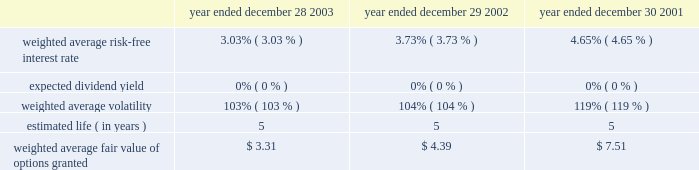Illumina , inc .
Notes to consolidated financial statements 2014 ( continued ) advertising costs the company expenses advertising costs as incurred .
Advertising costs were approximately $ 440000 for 2003 , $ 267000 for 2002 and $ 57000 for 2001 .
Income taxes a deferred income tax asset or liability is computed for the expected future impact of differences between the financial reporting and tax bases of assets and liabilities , as well as the expected future tax benefit to be derived from tax loss and credit carryforwards .
Deferred income tax expense is generally the net change during the year in the deferred income tax asset or liability .
Valuation allowances are established when realizability of deferred tax assets is uncertain .
The effect of tax rate changes is reflected in tax expense during the period in which such changes are enacted .
Foreign currency translation the functional currencies of the company 2019s wholly owned subsidiaries are their respective local currencies .
Accordingly , all balance sheet accounts of these operations are translated to u.s .
Dollars using the exchange rates in effect at the balance sheet date , and revenues and expenses are translated using the average exchange rates in effect during the period .
The gains and losses from foreign currency translation of these subsidiaries 2019 financial statements are recorded directly as a separate component of stockholders 2019 equity under the caption 2018 2018accumulated other comprehensive income . 2019 2019 stock-based compensation at december 28 , 2003 , the company has three stock-based employee and non-employee director compensation plans , which are described more fully in note 5 .
As permitted by sfas no .
123 , accounting for stock-based compensation , the company accounts for common stock options granted , and restricted stock sold , to employees , founders and directors using the intrinsic value method and , thus , recognizes no compensation expense for options granted , or restricted stock sold , with exercise prices equal to or greater than the fair value of the company 2019s common stock on the date of the grant .
The company has recorded deferred stock compensation related to certain stock options , and restricted stock , which were granted prior to the company 2019s initial public offering with exercise prices below estimated fair value ( see note 5 ) , which is being amortized on an accelerated amortiza- tion methodology in accordance with financial accounting standards board interpretation number ( 2018 2018fin 2019 2019 ) 28 .
Pro forma information regarding net loss is required by sfas no .
123 and has been determined as if the company had accounted for its employee stock options and employee stock purchases under the fair value method of that statement .
The fair value for these options was estimated at the dates of grant using the fair value option pricing model ( black scholes ) with the following weighted-average assumptions for 2003 , 2002 and 2001 : year ended year ended year ended december 28 , december 29 , december 30 , 2003 2002 2001 weighted average risk-free interest rate******* 3.03% ( 3.03 % ) 3.73% ( 3.73 % ) 4.65% ( 4.65 % ) expected dividend yield********************* 0% ( 0 % ) 0% ( 0 % ) 0% ( 0 % ) weighted average volatility ****************** 103% ( 103 % ) 104% ( 104 % ) 119% ( 119 % ) estimated life ( in years ) ********************** 5 5 5 .

What was the percent of the decline in the weighted average risk-free interest rate from 2002 to 2003? 
Computations: ((3.03 - 3.73) / 3.73)
Answer: -0.18767. 